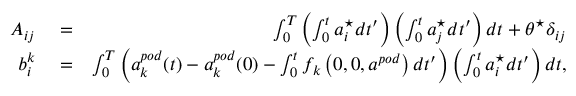Convert formula to latex. <formula><loc_0><loc_0><loc_500><loc_500>\begin{array} { r l r } { A _ { i j } } & = } & { \int _ { 0 } ^ { T } \left ( \int _ { 0 } ^ { t } a _ { i } ^ { ^ { * } } d t ^ { \prime } \right ) \left ( \int _ { 0 } ^ { t } a _ { j } ^ { ^ { * } } d t ^ { \prime } \right ) d t + \theta ^ { ^ { * } } \delta _ { i j } } \\ { b _ { i } ^ { k } } & = } & { \int _ { 0 } ^ { T } \left ( a _ { k } ^ { p o d } ( t ) - a _ { k } ^ { p o d } ( 0 ) - \int _ { 0 } ^ { t } f _ { k } \left ( 0 , 0 , a ^ { p o d } \right ) d t ^ { \prime } \right ) \left ( \int _ { 0 } ^ { t } a _ { i } ^ { ^ { * } } d t ^ { \prime } \right ) d t , } \end{array}</formula> 